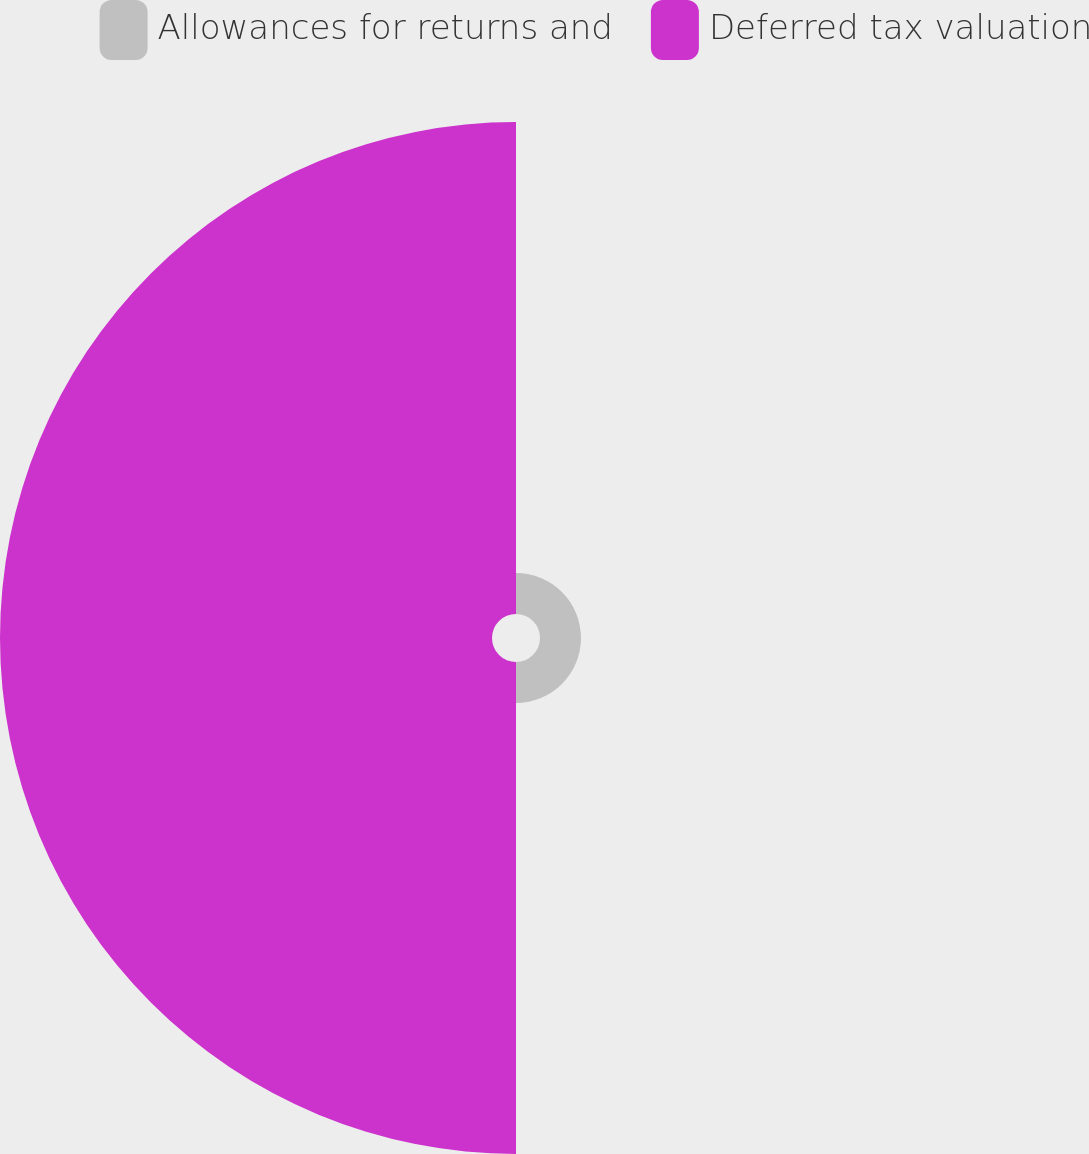<chart> <loc_0><loc_0><loc_500><loc_500><pie_chart><fcel>Allowances for returns and<fcel>Deferred tax valuation<nl><fcel>7.69%<fcel>92.31%<nl></chart> 